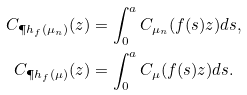<formula> <loc_0><loc_0><loc_500><loc_500>C _ { \P h _ { f } ( \mu _ { n } ) } ( z ) & = \int _ { 0 } ^ { a } C _ { \mu _ { n } } ( f ( s ) z ) d s , \\ C _ { \P h _ { f } ( \mu ) } ( z ) & = \int _ { 0 } ^ { a } C _ { \mu } ( f ( s ) z ) d s .</formula> 